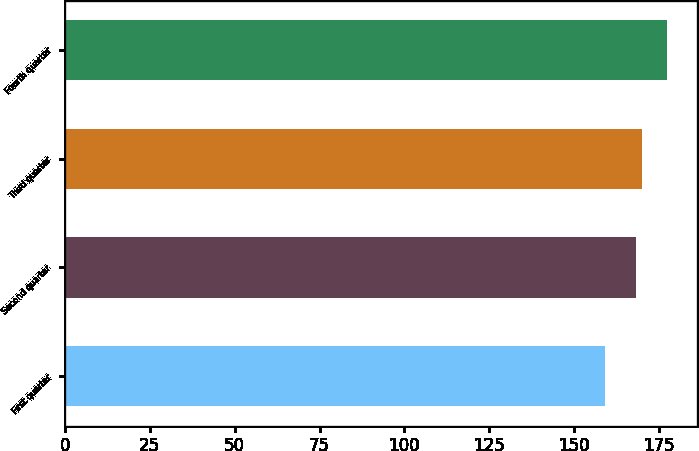<chart> <loc_0><loc_0><loc_500><loc_500><bar_chart><fcel>First quarter<fcel>Second quarter<fcel>Third quarter<fcel>Fourth quarter<nl><fcel>159<fcel>168.2<fcel>170.04<fcel>177.44<nl></chart> 